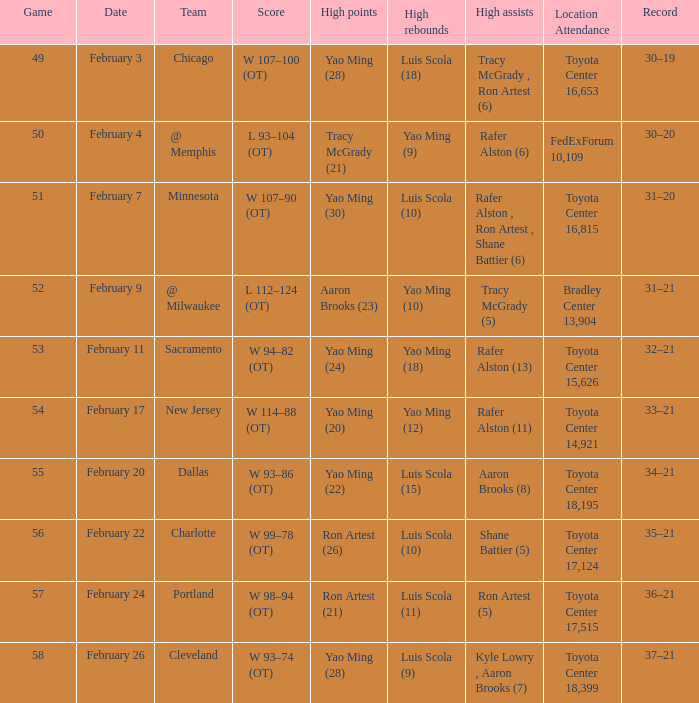Identify the record related to the 93-104 (ot) score. 30–20. 